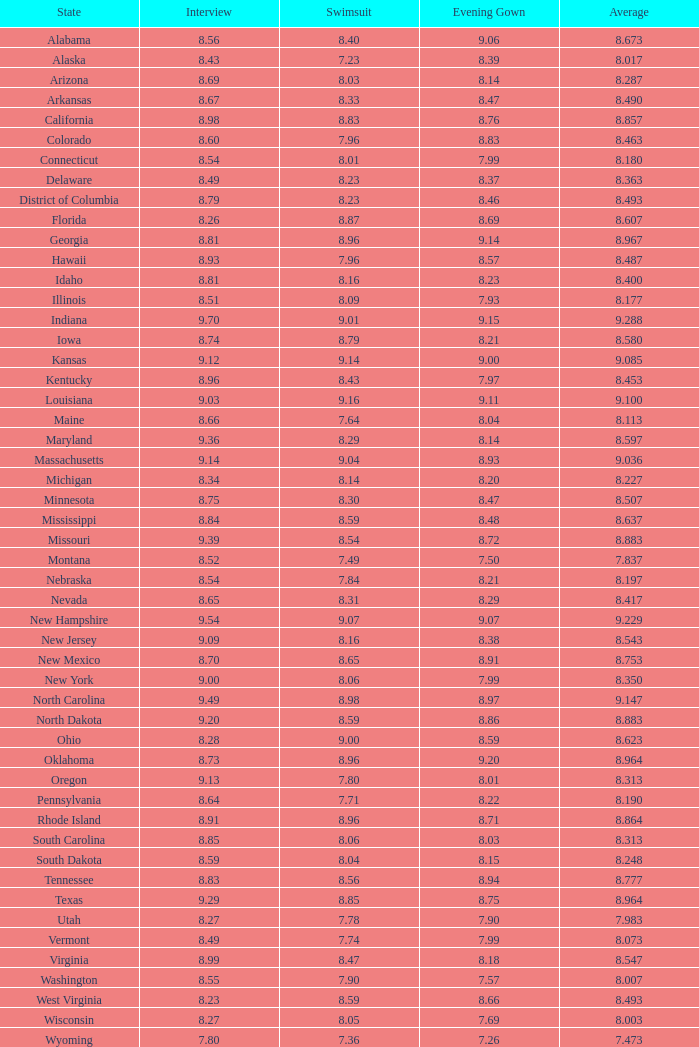Identify the state where the evening gown score is higher than 8.86, but the interview and swimsuit scores are lower than 8.7 and 8.96, respectively. Alabama. 